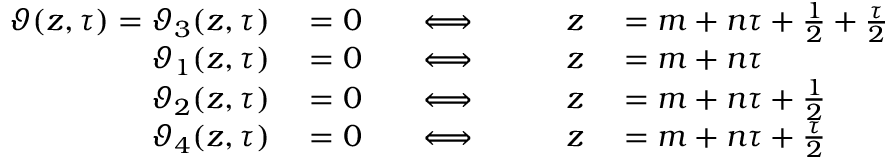Convert formula to latex. <formula><loc_0><loc_0><loc_500><loc_500>\begin{array} { r l r l r l } { \vartheta ( z , \tau ) = \vartheta _ { 3 } ( z , \tau ) } & = 0 \quad } & { \Longleftrightarrow } & { \quad z } & = m + n \tau + { \frac { 1 } { 2 } } + { \frac { \tau } { 2 } } } \\ { \vartheta _ { 1 } ( z , \tau ) } & = 0 \quad } & { \Longleftrightarrow } & { \quad z } & = m + n \tau } \\ { \vartheta _ { 2 } ( z , \tau ) } & = 0 \quad } & { \Longleftrightarrow } & { \quad z } & = m + n \tau + { \frac { 1 } { 2 } } } \\ { \vartheta _ { 4 } ( z , \tau ) } & = 0 \quad } & { \Longleftrightarrow } & { \quad z } & = m + n \tau + { \frac { \tau } { 2 } } } \end{array}</formula> 